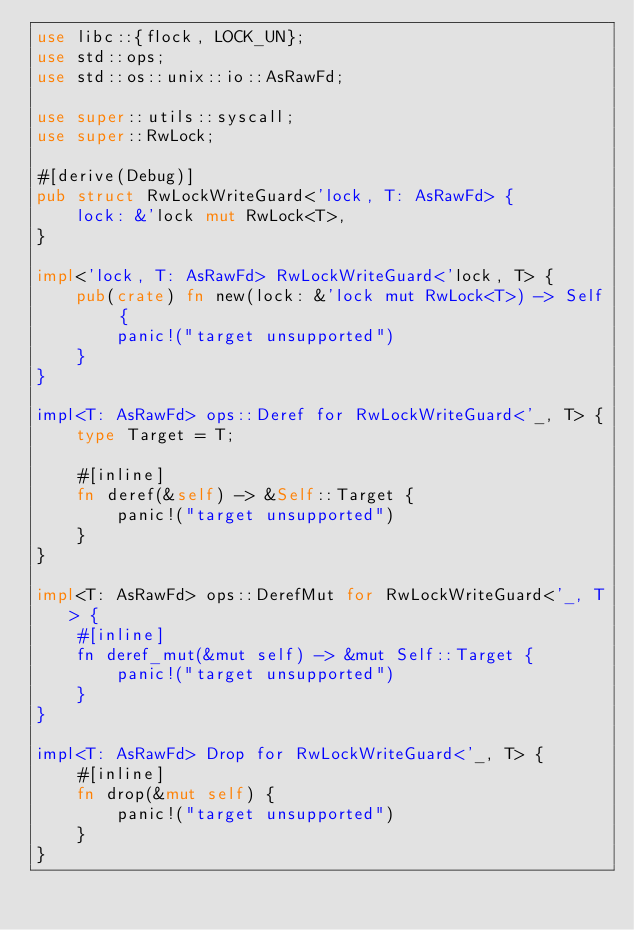<code> <loc_0><loc_0><loc_500><loc_500><_Rust_>use libc::{flock, LOCK_UN};
use std::ops;
use std::os::unix::io::AsRawFd;

use super::utils::syscall;
use super::RwLock;

#[derive(Debug)]
pub struct RwLockWriteGuard<'lock, T: AsRawFd> {
    lock: &'lock mut RwLock<T>,
}

impl<'lock, T: AsRawFd> RwLockWriteGuard<'lock, T> {
    pub(crate) fn new(lock: &'lock mut RwLock<T>) -> Self {
        panic!("target unsupported")
    }
}

impl<T: AsRawFd> ops::Deref for RwLockWriteGuard<'_, T> {
    type Target = T;

    #[inline]
    fn deref(&self) -> &Self::Target {
        panic!("target unsupported")
    }
}

impl<T: AsRawFd> ops::DerefMut for RwLockWriteGuard<'_, T> {
    #[inline]
    fn deref_mut(&mut self) -> &mut Self::Target {
        panic!("target unsupported")
    }
}

impl<T: AsRawFd> Drop for RwLockWriteGuard<'_, T> {
    #[inline]
    fn drop(&mut self) {
        panic!("target unsupported")
    }
}
</code> 